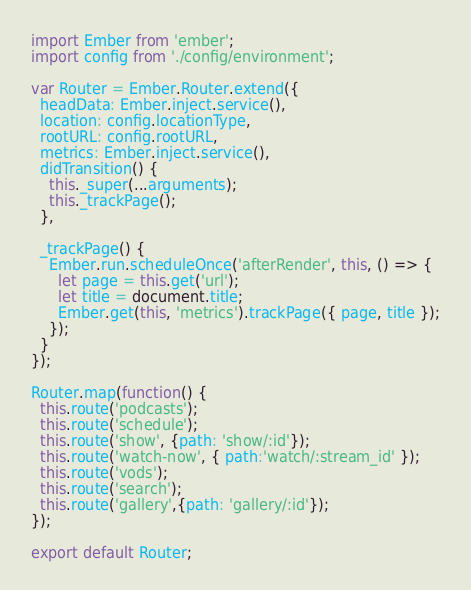<code> <loc_0><loc_0><loc_500><loc_500><_JavaScript_>import Ember from 'ember';
import config from './config/environment';

var Router = Ember.Router.extend({
  headData: Ember.inject.service(),
  location: config.locationType,
  rootURL: config.rootURL,
  metrics: Ember.inject.service(),
  didTransition() {
    this._super(...arguments);
    this._trackPage();
  },

  _trackPage() {
    Ember.run.scheduleOnce('afterRender', this, () => {
      let page = this.get('url');
      let title = document.title;
      Ember.get(this, 'metrics').trackPage({ page, title });
    });
  }
});

Router.map(function() {
  this.route('podcasts');
  this.route('schedule');
  this.route('show', {path: 'show/:id'});
  this.route('watch-now', { path:'watch/:stream_id' });
  this.route('vods');
  this.route('search');
  this.route('gallery',{path: 'gallery/:id'});
});

export default Router;
</code> 